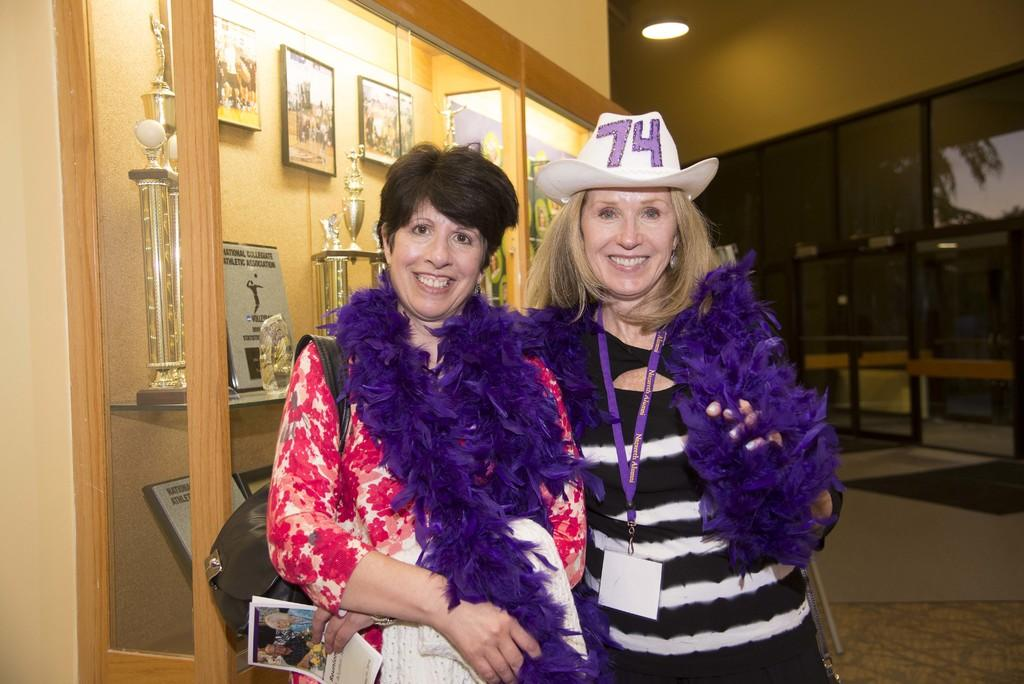How many women are in the image? There are two women in the image. What is one of the women holding in her hand? One woman is holding papers in her hand. What accessory is the woman holding papers wearing? The woman holding papers is wearing a handbag. What can be seen in the background of the image? Frames and shields are visible in the background of the image. Where are the frames and shields located? The frames and shields are inside a cupboard. What type of tongue can be seen licking the frames and shields in the image? There is no tongue visible in the image, and the frames and shields are inside a cupboard, so it is not possible to see a tongue licking them. 